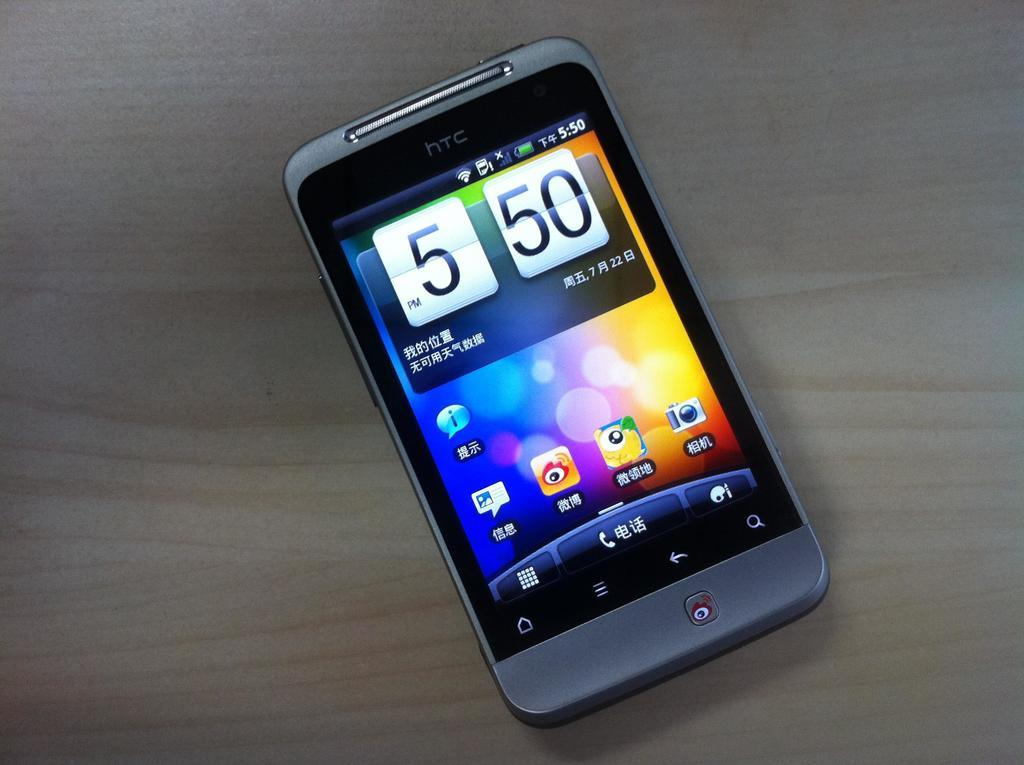<image>
Give a short and clear explanation of the subsequent image. A htc style smartphone with the time of 5:50 on its display. 